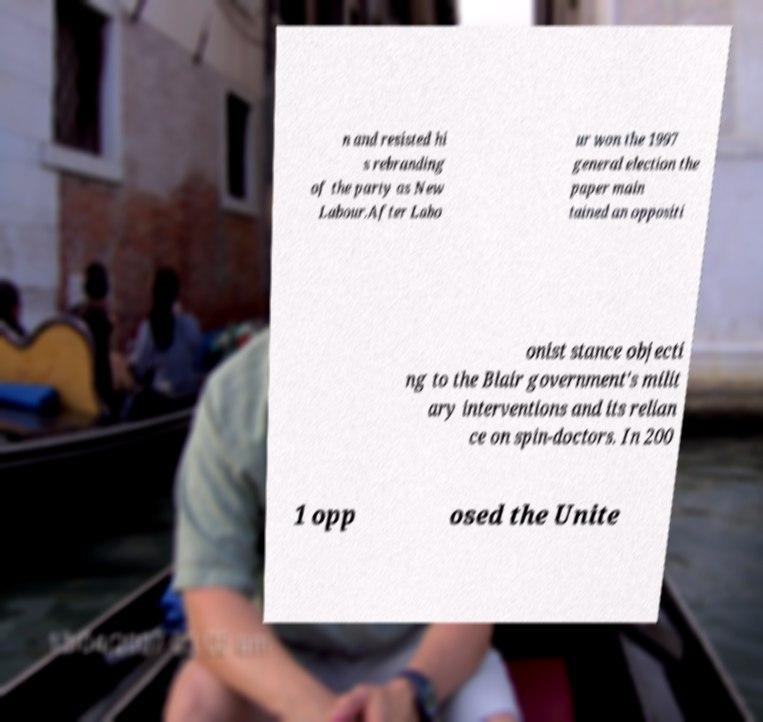There's text embedded in this image that I need extracted. Can you transcribe it verbatim? n and resisted hi s rebranding of the party as New Labour.After Labo ur won the 1997 general election the paper main tained an oppositi onist stance objecti ng to the Blair government's milit ary interventions and its relian ce on spin-doctors. In 200 1 opp osed the Unite 